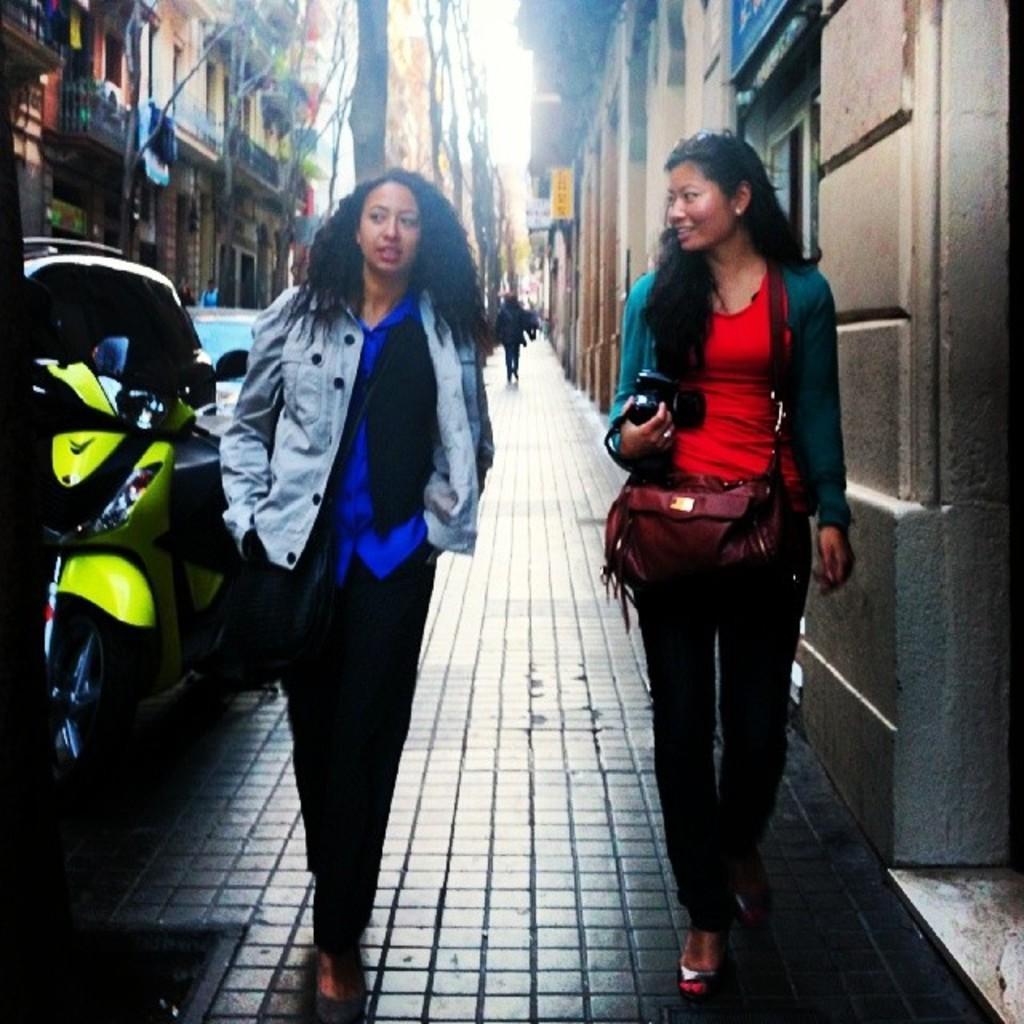Can you describe this image briefly? In this picture we can see two woman where one is holding camera in her hand and carrying bag and they are walking on foot path and in background we can see bike, building, trees, banner, some persons. 